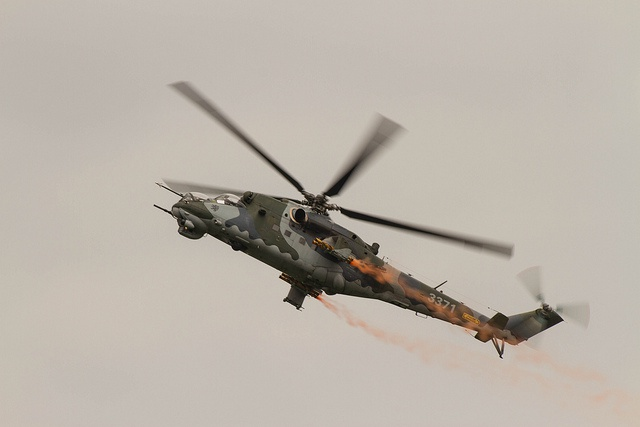Describe the objects in this image and their specific colors. I can see various objects in this image with different colors. 